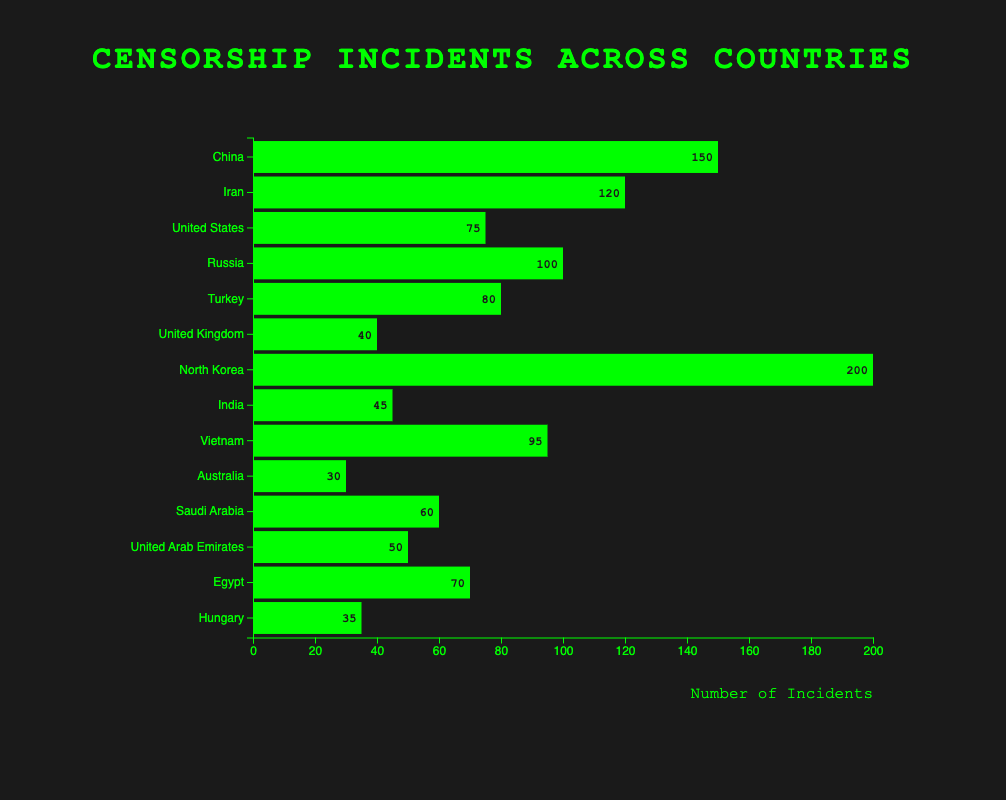Which country has the highest number of censorship incidents? The bar chart shows that North Korea has the highest number of censorship incidents with a length representing 200 incidents, which is the longest bar in the chart.
Answer: North Korea In which country do schools face the highest number of book bans? The bar labeled "Book Bans" under "Schools" represents the United States, with a length showing 75 incidents, which is the highest in the category.
Answer: United States How does the number of incidents in Russia compare to Vietnam for internet censorship? The bar representing "Internet Censorship" incidents for Russia reaches 100, while the corresponding bar for Vietnam reaches 95. Therefore, Russia has more incidents than Vietnam in this category.
Answer: Russia has more incidents Which institution is responsible for the highest number of censorship incidents in Egypt? The chart shows only "Government" as the institution responsible for censorship incidents in Egypt, with a bar length representing 70 incidents.
Answer: Government What is the difference in the number of internet censorship incidents between China and Iran? China has 150 incidents of internet censorship, whereas Iran has 120. The difference is calculated as 150 - 120.
Answer: 30 Sum the total number of news media bans in Turkey, Saudi Arabia, and Hungary. The incidents for news media bans in Turkey, Saudi Arabia, and Hungary are shown as 80, 60, and 35, respectively. Their sum is 80 + 60 + 35.
Answer: 175 What type of censorship incident is most common in the data? By visually assessing the different bar categories, "Internet Censorship" incidents are most common, having multiple countries with high numbers.
Answer: Internet Censorship Compare the number of book bans in the United States to the number of social media bans in India. Which is higher? The chart shows 75 incidents of book bans in the United States and 45 incidents of social media bans in India. Therefore, book bans in the United States are higher.
Answer: Book bans in the United States What is the combined number of censorship incidents by governments in China, Iran, and Russia? The numbers for China, Iran, and Russia are 150, 120, and 100 respectively. The combined total is 150 + 120 + 100.
Answer: 370 Which country has the fewest number of book bans, and what is the number? The chart shows that Australia has the fewest book bans with a bar representing 30 incidents.
Answer: Australia with 30 